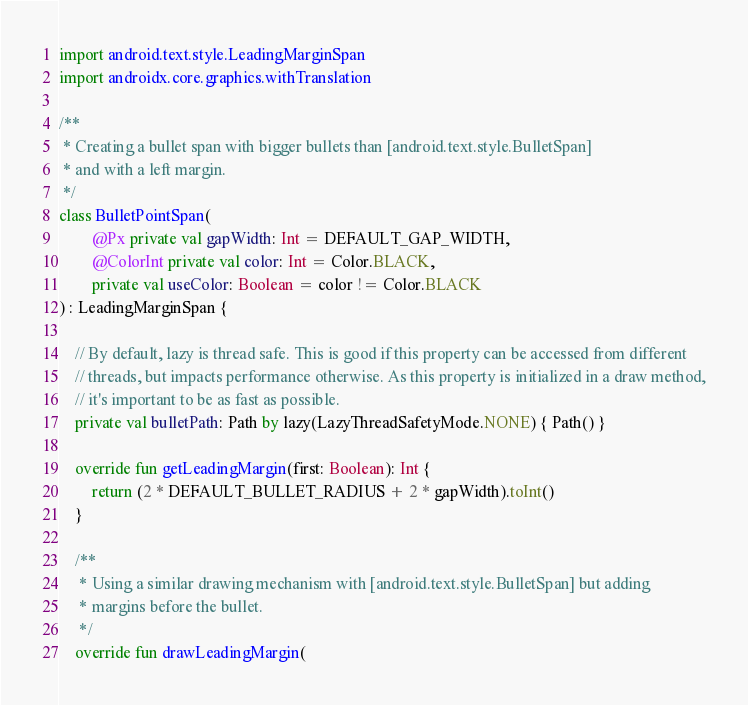<code> <loc_0><loc_0><loc_500><loc_500><_Kotlin_>import android.text.style.LeadingMarginSpan
import androidx.core.graphics.withTranslation

/**
 * Creating a bullet span with bigger bullets than [android.text.style.BulletSpan]
 * and with a left margin.
 */
class BulletPointSpan(
        @Px private val gapWidth: Int = DEFAULT_GAP_WIDTH,
        @ColorInt private val color: Int = Color.BLACK,
        private val useColor: Boolean = color != Color.BLACK
) : LeadingMarginSpan {

    // By default, lazy is thread safe. This is good if this property can be accessed from different
    // threads, but impacts performance otherwise. As this property is initialized in a draw method,
    // it's important to be as fast as possible.
    private val bulletPath: Path by lazy(LazyThreadSafetyMode.NONE) { Path() }

    override fun getLeadingMargin(first: Boolean): Int {
        return (2 * DEFAULT_BULLET_RADIUS + 2 * gapWidth).toInt()
    }

    /**
     * Using a similar drawing mechanism with [android.text.style.BulletSpan] but adding
     * margins before the bullet.
     */
    override fun drawLeadingMargin(</code> 